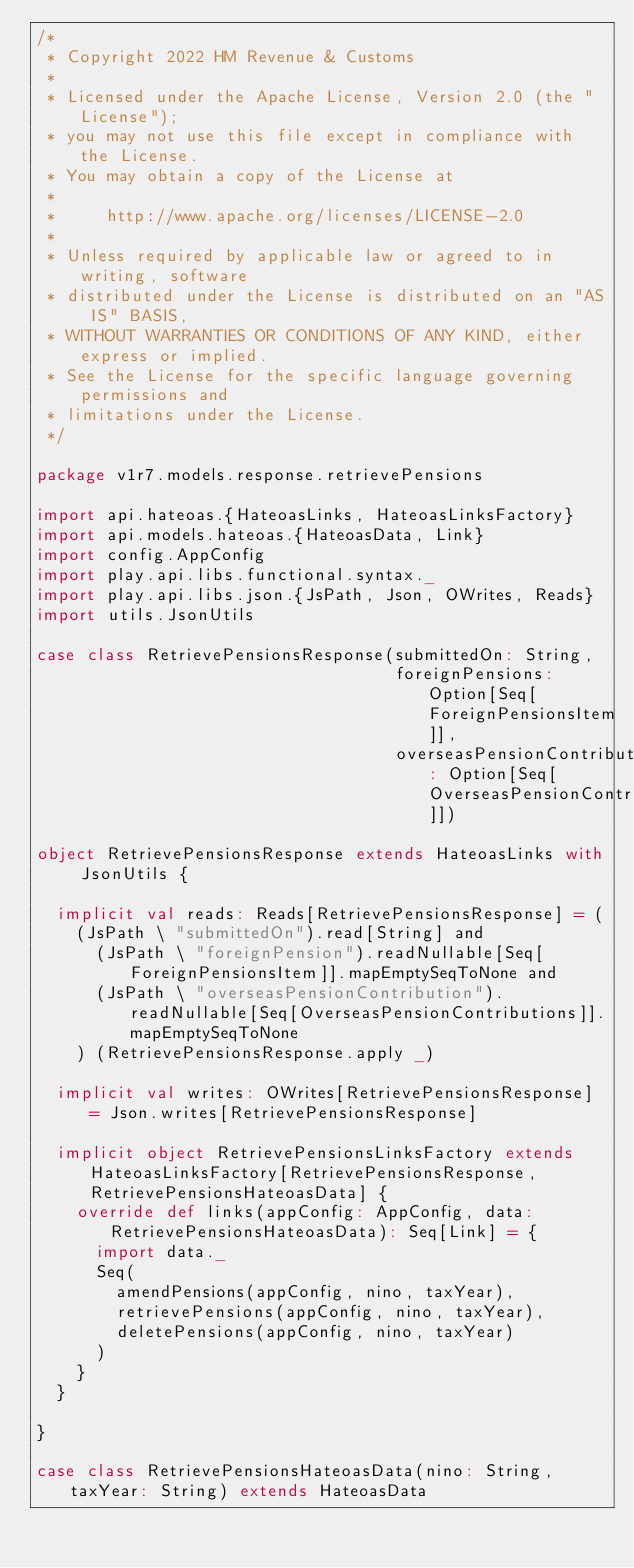<code> <loc_0><loc_0><loc_500><loc_500><_Scala_>/*
 * Copyright 2022 HM Revenue & Customs
 *
 * Licensed under the Apache License, Version 2.0 (the "License");
 * you may not use this file except in compliance with the License.
 * You may obtain a copy of the License at
 *
 *     http://www.apache.org/licenses/LICENSE-2.0
 *
 * Unless required by applicable law or agreed to in writing, software
 * distributed under the License is distributed on an "AS IS" BASIS,
 * WITHOUT WARRANTIES OR CONDITIONS OF ANY KIND, either express or implied.
 * See the License for the specific language governing permissions and
 * limitations under the License.
 */

package v1r7.models.response.retrievePensions

import api.hateoas.{HateoasLinks, HateoasLinksFactory}
import api.models.hateoas.{HateoasData, Link}
import config.AppConfig
import play.api.libs.functional.syntax._
import play.api.libs.json.{JsPath, Json, OWrites, Reads}
import utils.JsonUtils

case class RetrievePensionsResponse(submittedOn: String,
                                    foreignPensions: Option[Seq[ForeignPensionsItem]],
                                    overseasPensionContributions: Option[Seq[OverseasPensionContributions]])

object RetrievePensionsResponse extends HateoasLinks with JsonUtils {

  implicit val reads: Reads[RetrievePensionsResponse] = (
    (JsPath \ "submittedOn").read[String] and
      (JsPath \ "foreignPension").readNullable[Seq[ForeignPensionsItem]].mapEmptySeqToNone and
      (JsPath \ "overseasPensionContribution").readNullable[Seq[OverseasPensionContributions]].mapEmptySeqToNone
    ) (RetrievePensionsResponse.apply _)

  implicit val writes: OWrites[RetrievePensionsResponse] = Json.writes[RetrievePensionsResponse]

  implicit object RetrievePensionsLinksFactory extends HateoasLinksFactory[RetrievePensionsResponse, RetrievePensionsHateoasData] {
    override def links(appConfig: AppConfig, data: RetrievePensionsHateoasData): Seq[Link] = {
      import data._
      Seq(
        amendPensions(appConfig, nino, taxYear),
        retrievePensions(appConfig, nino, taxYear),
        deletePensions(appConfig, nino, taxYear)
      )
    }
  }

}

case class RetrievePensionsHateoasData(nino: String, taxYear: String) extends HateoasData</code> 